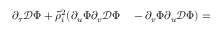Convert formula to latex. <formula><loc_0><loc_0><loc_500><loc_500>\begin{array} { r l } { \partial _ { \tau } \mathcal { D } \Phi + \tilde { \rho } _ { i } ^ { 2 } ( \partial _ { u } \Phi \partial _ { v } \mathcal { D } \Phi } & - \partial _ { v } \Phi \partial _ { u } \mathcal { D } \Phi ) = } \end{array}</formula> 